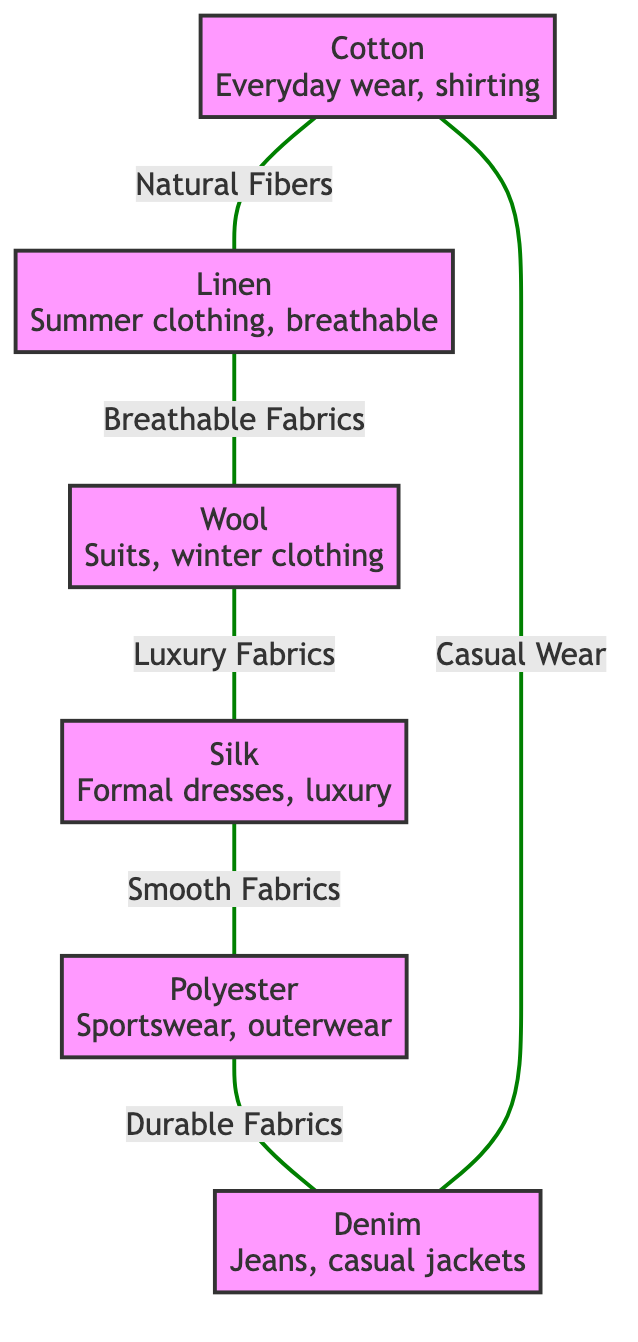What fabric is used for everyday wear? According to the node labeled "Cotton," it is associated with the use case of "Everyday wear, shirting, and casual outfits."
Answer: Cotton How many nodes are present in the diagram? By counting the listed fabrics, we find that there are six nodes in total: Cotton, Linen, Wool, Silk, Polyester, and Denim.
Answer: 6 What is the relationship between Wool and Silk? The edge connecting Wool and Silk indicates that they are categorized as "Luxury Fabrics," showing a direct relationship of fabric quality.
Answer: Luxury Fabrics Which fabric is the best choice for summer clothing? The node labeled "Linen" specifies its use case as "Summer clothing, breathable apparel, and casual wear," identifying it as the best choice for that purpose.
Answer: Linen What are the two fabrics connected by "Durable Fabrics"? Following the edge labeled "Durable Fabrics," we see that Polyester connects to Denim, indicating that these two fabrics share this quality.
Answer: Polyester, Denim What use case is associated with Silk? The node corresponding to Silk provides the information that it is used for "Formal dresses, luxury garments, and lingerie."
Answer: Formal dresses, luxury garments, and lingerie What type of fabric is Denim primarily used for? The node for Denim clarifies that its primary use cases include "Jeans, casual jackets, and durable clothing."
Answer: Jeans, casual jackets, and durable clothing Which fabric connects back to Cotton indicating "Casual Wear"? The diagram shows that Denim has an edge connecting back to Cotton, with the label specifying it as "Casual Wear," indicating Denim's relationship to Cotton.
Answer: Denim What commonality do Cotton and Linen share? The edge labeled "Natural Fibers" between Cotton and Linen signifies that both fabrics belong to the category of natural fibers.
Answer: Natural Fibers 